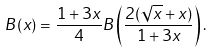<formula> <loc_0><loc_0><loc_500><loc_500>B ( x ) = \frac { 1 + 3 x } { 4 } B \left ( \frac { 2 ( \sqrt { x } + x ) } { 1 + 3 x } \right ) .</formula> 